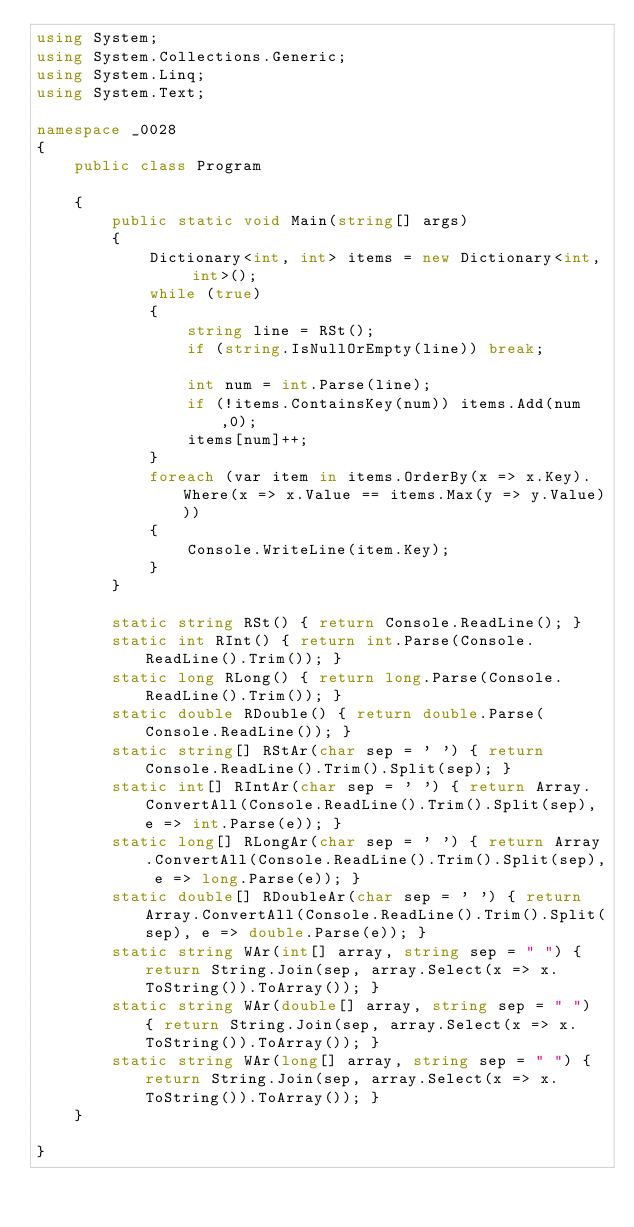Convert code to text. <code><loc_0><loc_0><loc_500><loc_500><_C#_>using System;
using System.Collections.Generic;
using System.Linq;
using System.Text;

namespace _0028
{
    public class Program

    {
        public static void Main(string[] args)
        {
            Dictionary<int, int> items = new Dictionary<int, int>();
            while (true)
            {
                string line = RSt();
                if (string.IsNullOrEmpty(line)) break;

                int num = int.Parse(line);
                if (!items.ContainsKey(num)) items.Add(num,0); 
                items[num]++;
            }
            foreach (var item in items.OrderBy(x => x.Key).Where(x => x.Value == items.Max(y => y.Value)))
            {
                Console.WriteLine(item.Key);
            }
        }

        static string RSt() { return Console.ReadLine(); }
        static int RInt() { return int.Parse(Console.ReadLine().Trim()); }
        static long RLong() { return long.Parse(Console.ReadLine().Trim()); }
        static double RDouble() { return double.Parse(Console.ReadLine()); }
        static string[] RStAr(char sep = ' ') { return Console.ReadLine().Trim().Split(sep); }
        static int[] RIntAr(char sep = ' ') { return Array.ConvertAll(Console.ReadLine().Trim().Split(sep), e => int.Parse(e)); }
        static long[] RLongAr(char sep = ' ') { return Array.ConvertAll(Console.ReadLine().Trim().Split(sep), e => long.Parse(e)); }
        static double[] RDoubleAr(char sep = ' ') { return Array.ConvertAll(Console.ReadLine().Trim().Split(sep), e => double.Parse(e)); }
        static string WAr(int[] array, string sep = " ") { return String.Join(sep, array.Select(x => x.ToString()).ToArray()); }
        static string WAr(double[] array, string sep = " ") { return String.Join(sep, array.Select(x => x.ToString()).ToArray()); }
        static string WAr(long[] array, string sep = " ") { return String.Join(sep, array.Select(x => x.ToString()).ToArray()); }
    }

}

</code> 